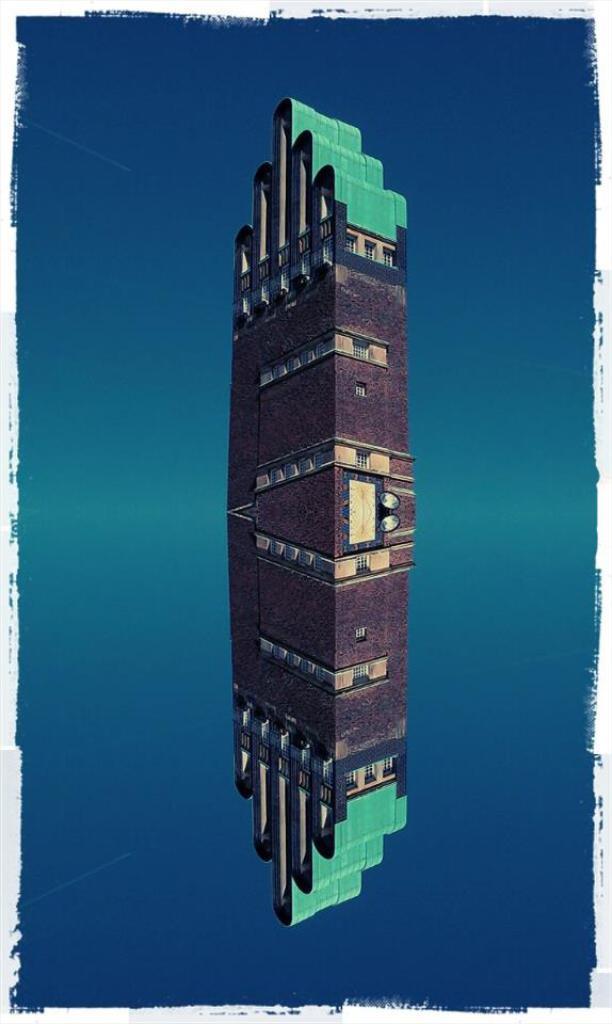Could you give a brief overview of what you see in this image? In this image, we can see a building and there is a blue color background. 